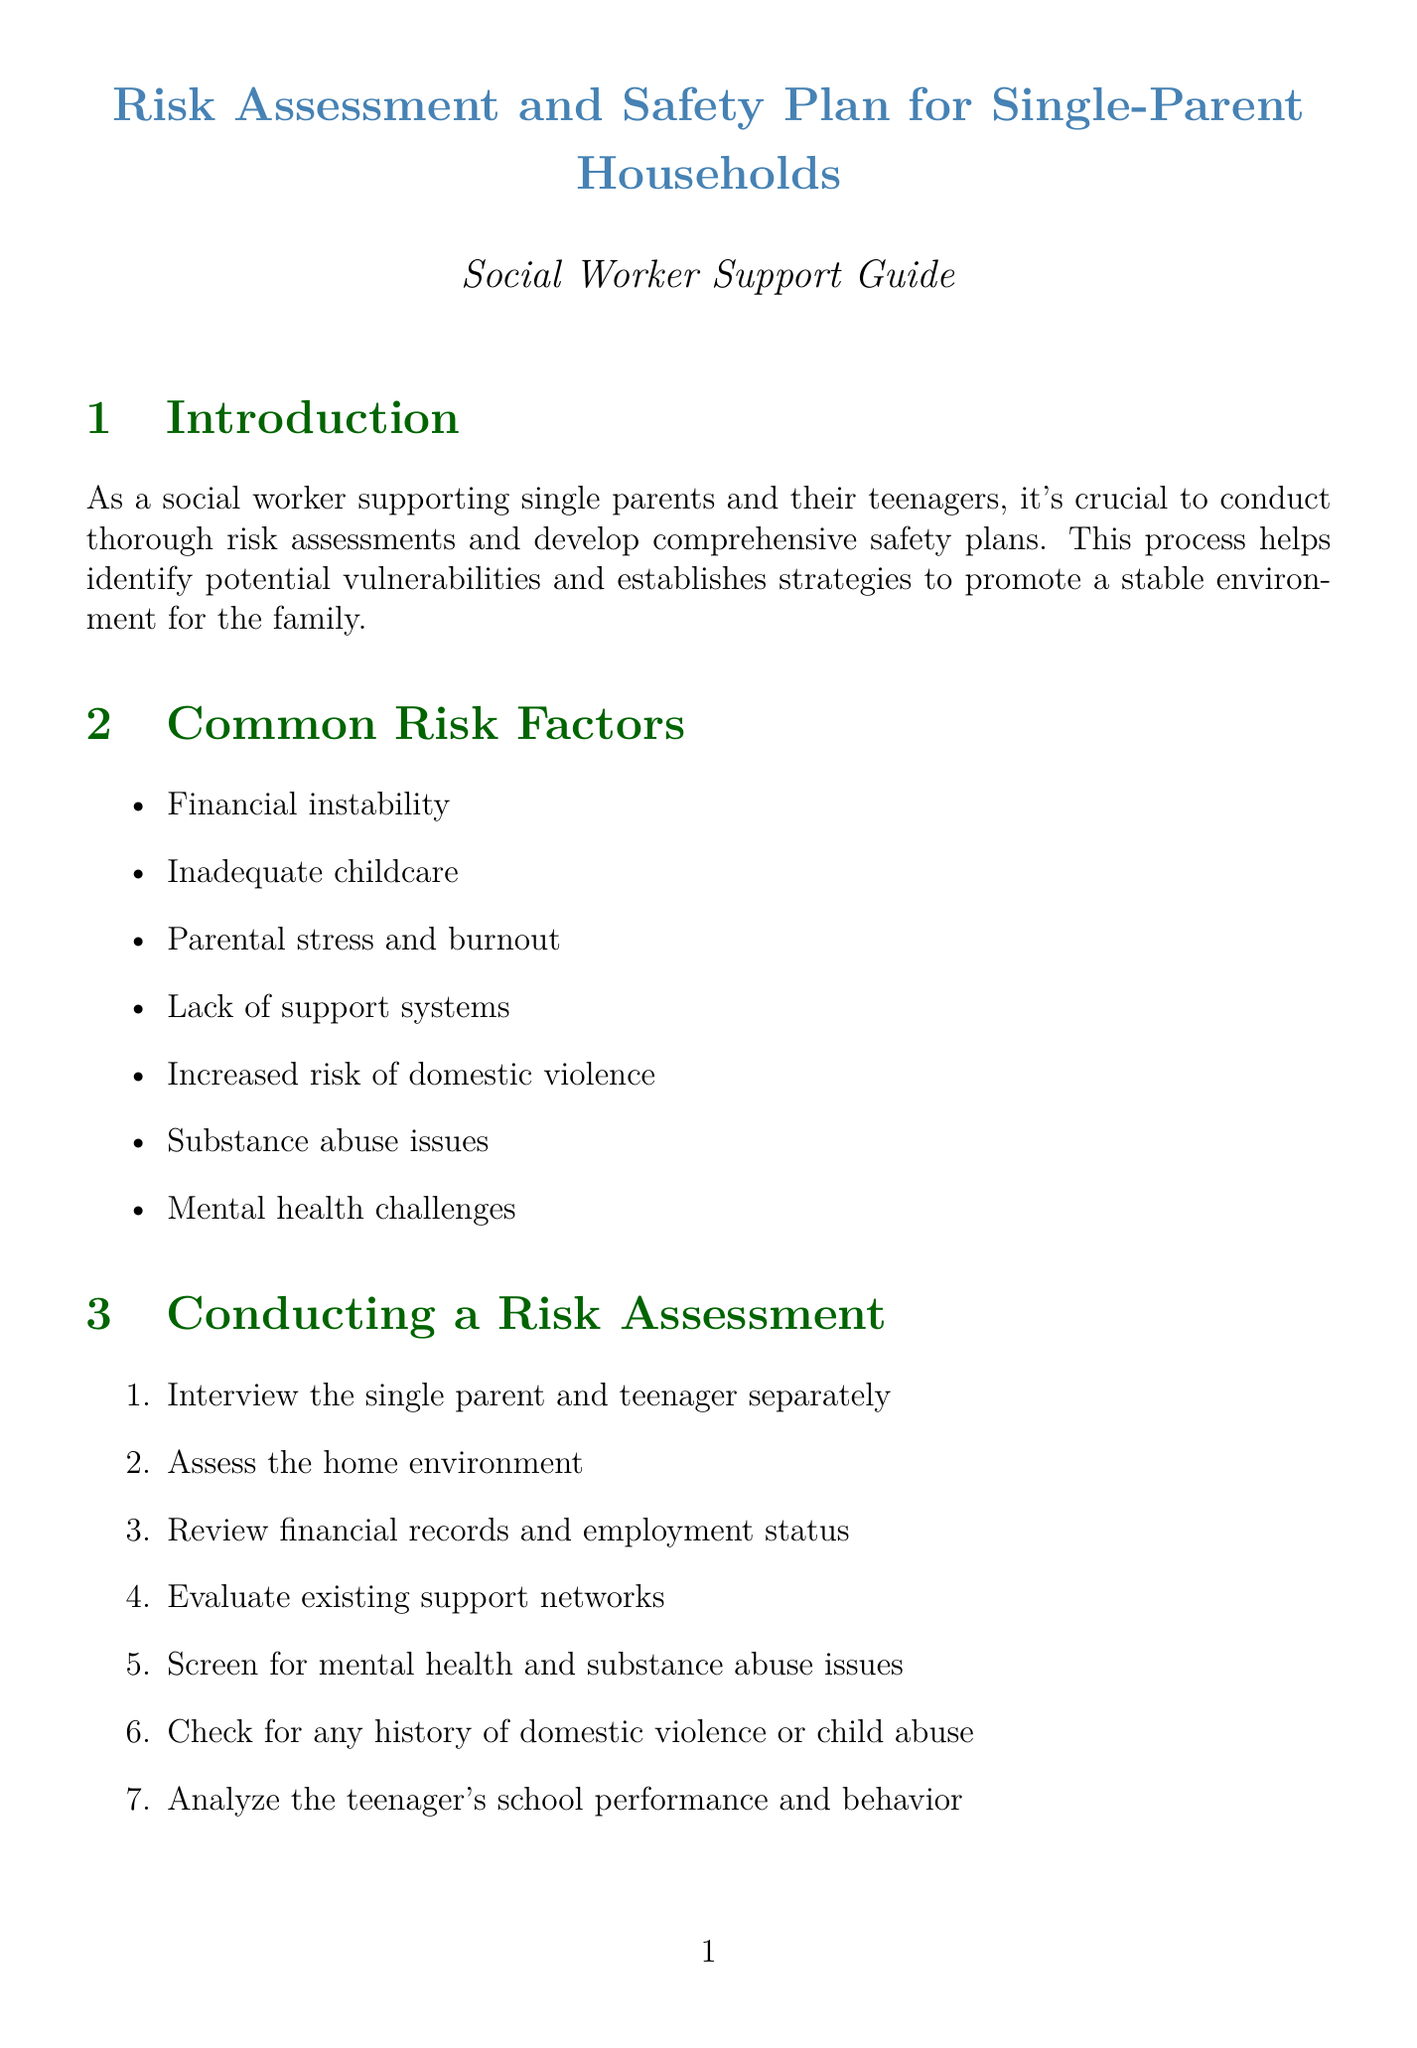What is the focus of the report? The report focuses on conducting risk assessments and developing safety plans for single-parent households.
Answer: Risk assessments and safety plans for single-parent households What are two common risk factors mentioned? Common risk factors listed in the document include financial instability and inadequate childcare.
Answer: Financial instability, inadequate childcare How many steps are in the risk assessment process? The risk assessment section lists seven distinct steps to follow during the assessment process.
Answer: Seven Name one component of the safety plan. The safety plan includes an emergency contact list among other components.
Answer: Emergency contact list What is one strategy to address domestic issues? One strategy provided in the document is conflict resolution training.
Answer: Conflict resolution training Which family member is enrolled in a counseling program? The document specifies that the teenager, Michael Johnson, is enrolled in a teen counseling program.
Answer: Michael Johnson What is a measure to promote a stable environment related to support? One measure related to the support network is connecting with local single-parent support groups.
Answer: Connect with local single-parent support groups How often should check-ins with the family be scheduled according to the document? The document suggests scheduling regular check-ins to monitor the family's situation.
Answer: Regularly 